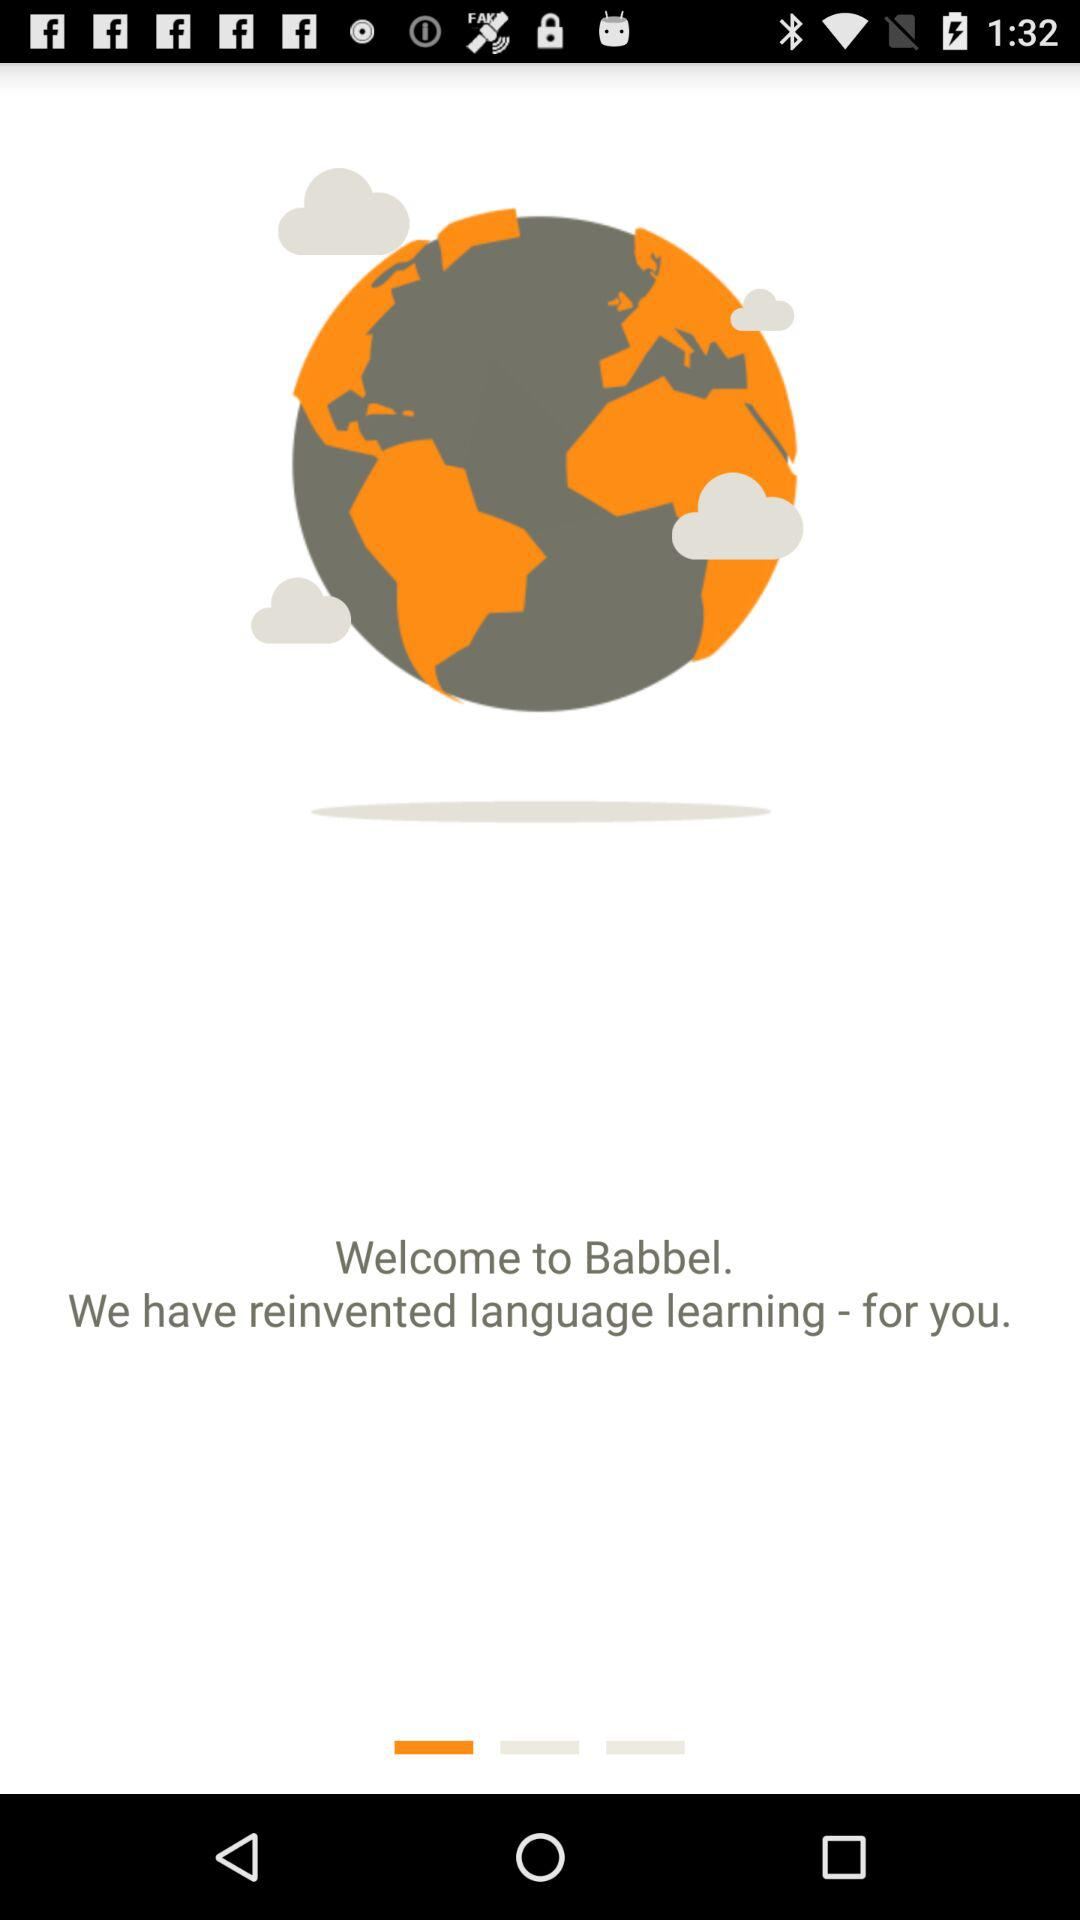What is the app name? The app name is "Babbel". 